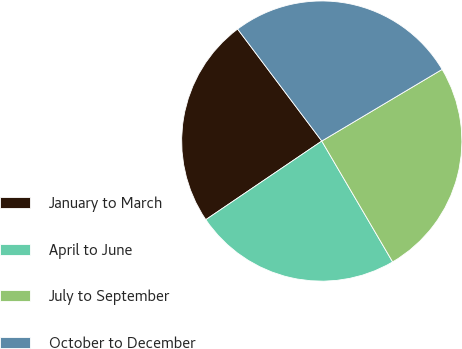Convert chart to OTSL. <chart><loc_0><loc_0><loc_500><loc_500><pie_chart><fcel>January to March<fcel>April to June<fcel>July to September<fcel>October to December<nl><fcel>24.23%<fcel>23.96%<fcel>25.11%<fcel>26.71%<nl></chart> 